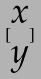Convert formula to latex. <formula><loc_0><loc_0><loc_500><loc_500>[ \begin{matrix} x \\ y \end{matrix} ]</formula> 